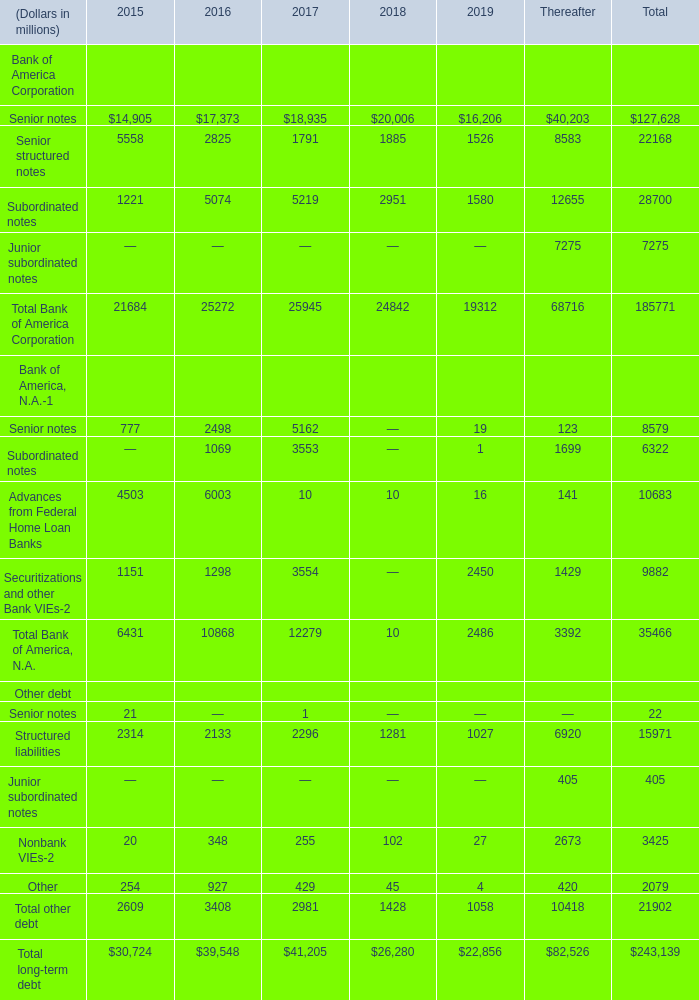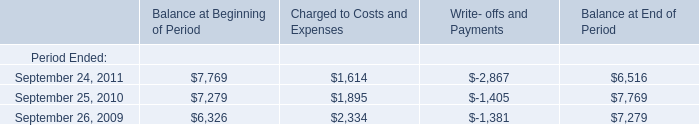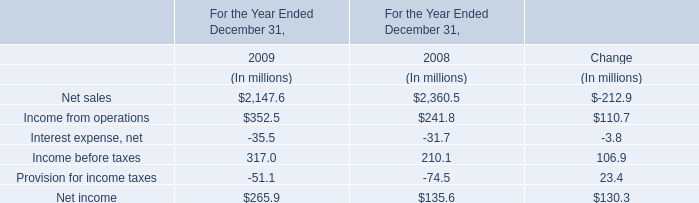what's the total amount of Structured liabilities Other debt of Thereafter, September 24, 2011 of Balance at End of Period, and Total Bank of America, N.A. Bank of America, N.A. of Thereafter ? 
Computations: ((6920.0 + 6516.0) + 3392.0)
Answer: 16828.0. 